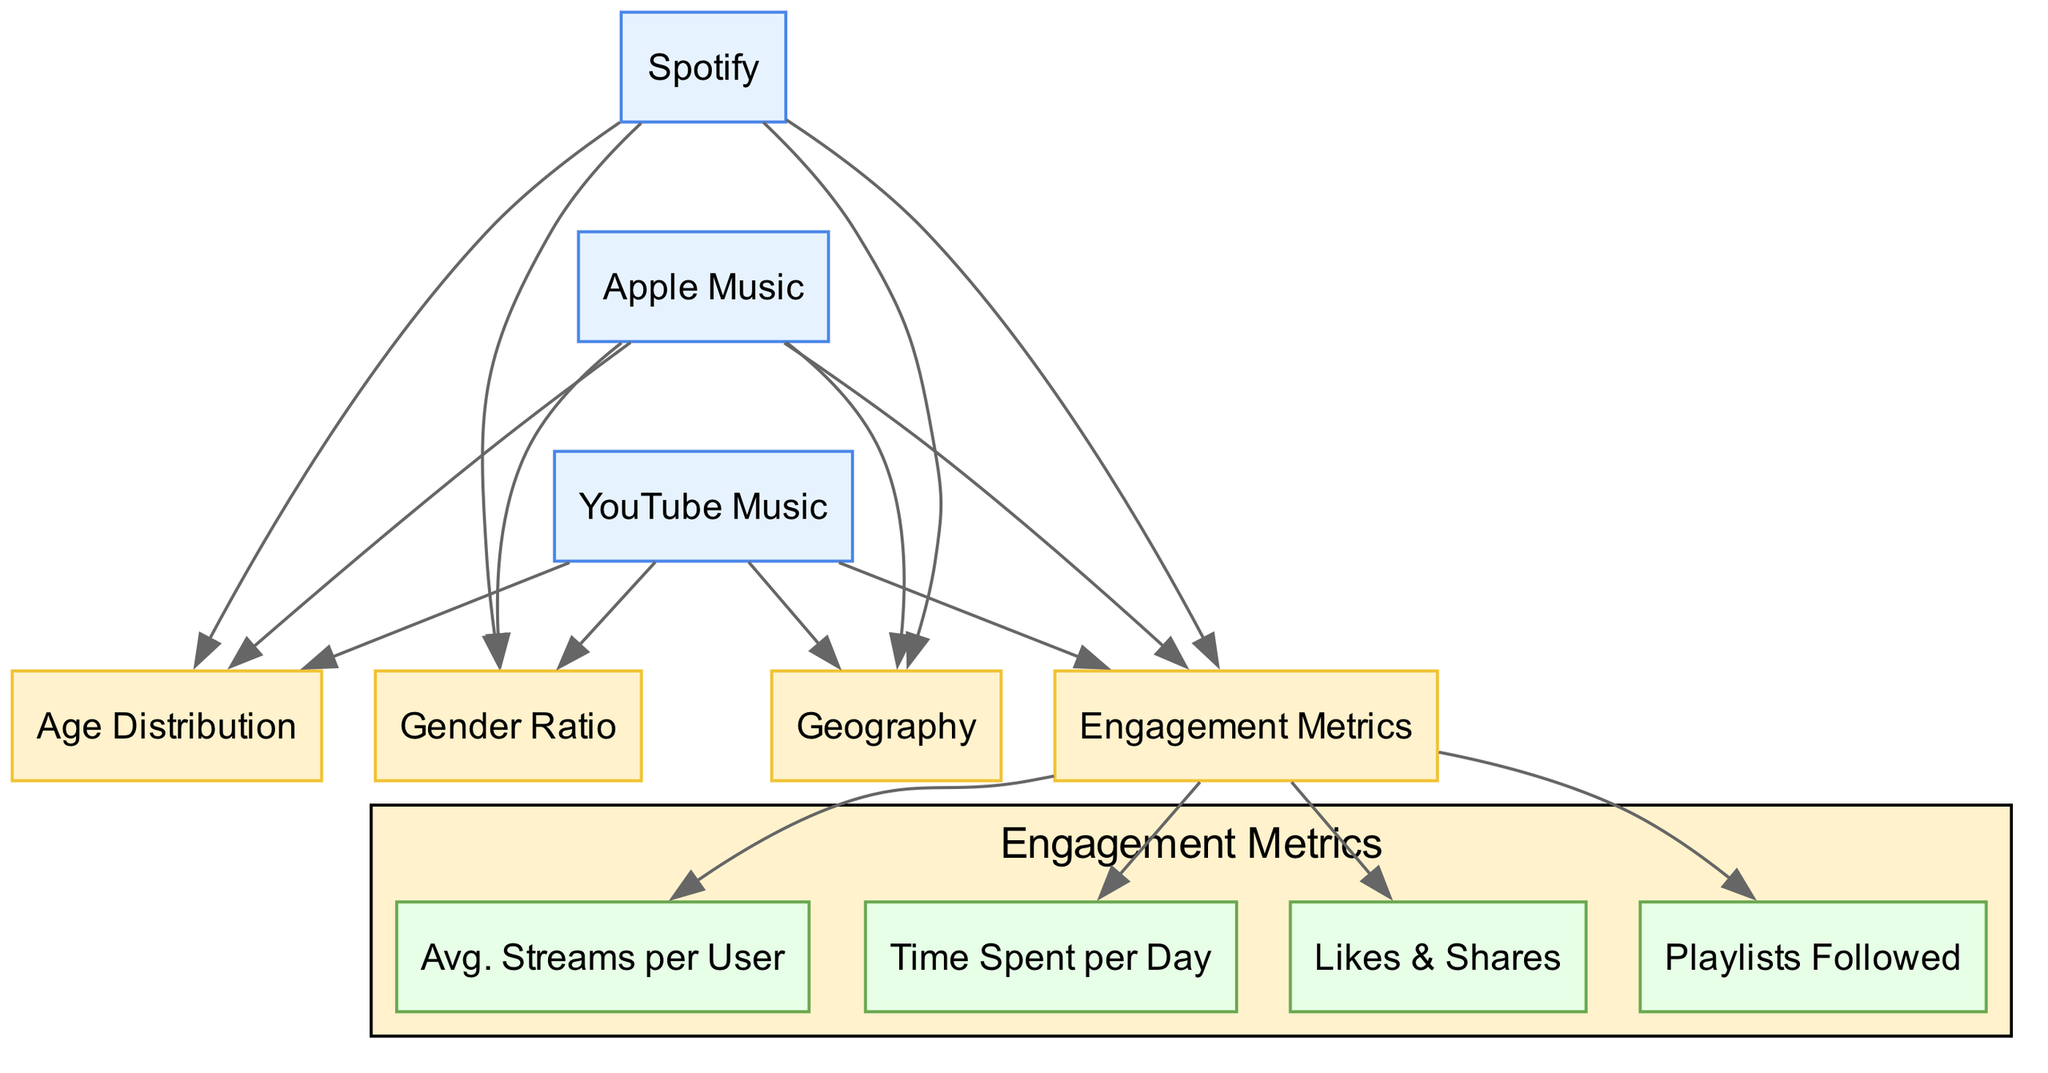What platforms are compared in the diagram? The diagram outlines three streaming platforms identified as Spotify, Apple Music, and YouTube Music. Each platform is represented as a node, making it clear which services are being compared in terms of demographics and engagement metrics.
Answer: Spotify, Apple Music, YouTube Music How many nodes represent engagement metrics in the diagram? The engagement metrics are shown as a cluster node that contains four specific metrics represented as individual nodes. Counting these nodes reveals that there are four engagement metrics in total: Avg. Streams per User, Time Spent per Day, Likes & Shares, and Playlists Followed.
Answer: 4 Which platform has a direct connection to the gender ratio? After examining the edges connecting nodes, you will find that both Spotify, Apple Music, and YouTube Music have direct connections to the gender ratio. This indicates that each platform collects data on the gender demographics of its users, and this information is reflected in the diagram.
Answer: Spotify, Apple Music, YouTube Music What type of information is included in the age distribution node? The age distribution node indicates the demographic breakdown of users by age groups for each streaming platform. This information is vital for understanding which age segments are engaging with each service.
Answer: Demographic breakdown by age Which platform has the highest average streams per user? To determine which platform has the highest average streams per user, one would need to evaluate the specific metrics displayed under the engagement metrics cluster. If a specific number is given, it would indicate which platform leads in terms of this engagement metric. However, the actual values are not provided in the data.
Answer: (Refer to specific values in the diagram) How does the geographic information relate to the streaming platforms? Each platform has a direct node to the geography information, illustrating that geographic data is a key consideration for all three streaming services. This indicates that user location might influence platform popularity and engagement strategies.
Answer: Geographic data is relevant for all platforms 